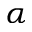Convert formula to latex. <formula><loc_0><loc_0><loc_500><loc_500>\alpha</formula> 